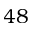Convert formula to latex. <formula><loc_0><loc_0><loc_500><loc_500>4 8</formula> 